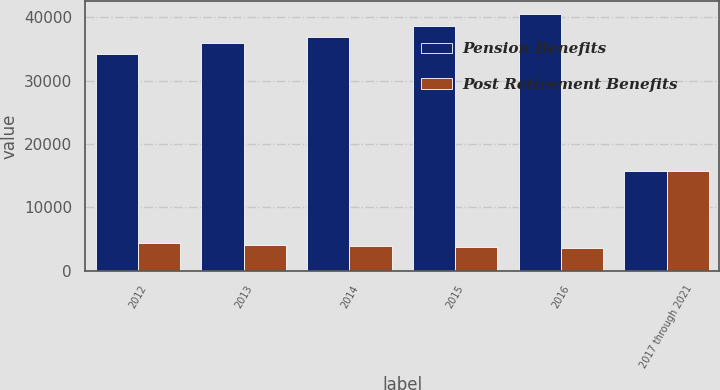Convert chart. <chart><loc_0><loc_0><loc_500><loc_500><stacked_bar_chart><ecel><fcel>2012<fcel>2013<fcel>2014<fcel>2015<fcel>2016<fcel>2017 through 2021<nl><fcel>Pension Benefits<fcel>34124<fcel>36006<fcel>36874<fcel>38573<fcel>40533<fcel>15694<nl><fcel>Post Retirement Benefits<fcel>4297<fcel>4110<fcel>3923<fcel>3759<fcel>3588<fcel>15694<nl></chart> 